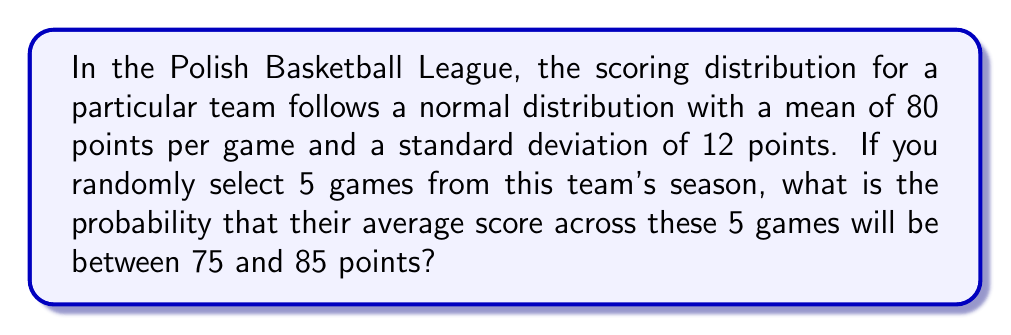Provide a solution to this math problem. Let's approach this step-by-step:

1) We're dealing with a sample mean of 5 games. The Central Limit Theorem tells us that the distribution of sample means will also be normally distributed.

2) The mean of the sampling distribution will be the same as the population mean: $\mu_{\bar{X}} = 80$

3) The standard error (standard deviation of the sampling distribution) is given by:
   $$\sigma_{\bar{X}} = \frac{\sigma}{\sqrt{n}} = \frac{12}{\sqrt{5}} = 5.37$$

4) We want to find $P(75 < \bar{X} < 85)$

5) To use the standard normal distribution, we need to standardize these values:
   $$z_1 = \frac{75 - 80}{5.37} = -0.93$$
   $$z_2 = \frac{85 - 80}{5.37} = 0.93$$

6) Now we're looking for $P(-0.93 < Z < 0.93)$

7) Using a standard normal table or calculator:
   $P(Z < 0.93) = 0.8238$
   $P(Z < -0.93) = 0.1762$

8) The probability we're looking for is:
   $P(-0.93 < Z < 0.93) = 0.8238 - 0.1762 = 0.6476$

Therefore, the probability that the team's average score across 5 randomly selected games will be between 75 and 85 points is approximately 0.6476 or 64.76%.
Answer: 0.6476 